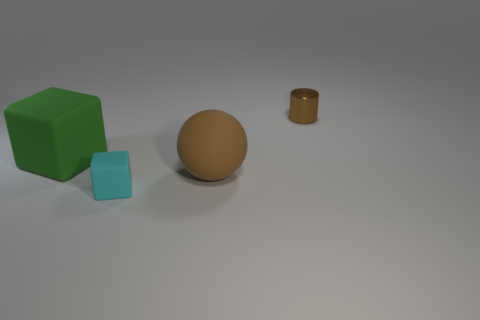Add 3 large spheres. How many objects exist? 7 Subtract all cyan blocks. How many blocks are left? 1 Subtract all balls. How many objects are left? 3 Subtract all brown cubes. Subtract all yellow cylinders. How many cubes are left? 2 Subtract all tiny cylinders. Subtract all brown cylinders. How many objects are left? 2 Add 4 tiny cyan rubber cubes. How many tiny cyan rubber cubes are left? 5 Add 1 cyan metal balls. How many cyan metal balls exist? 1 Subtract 0 gray cylinders. How many objects are left? 4 